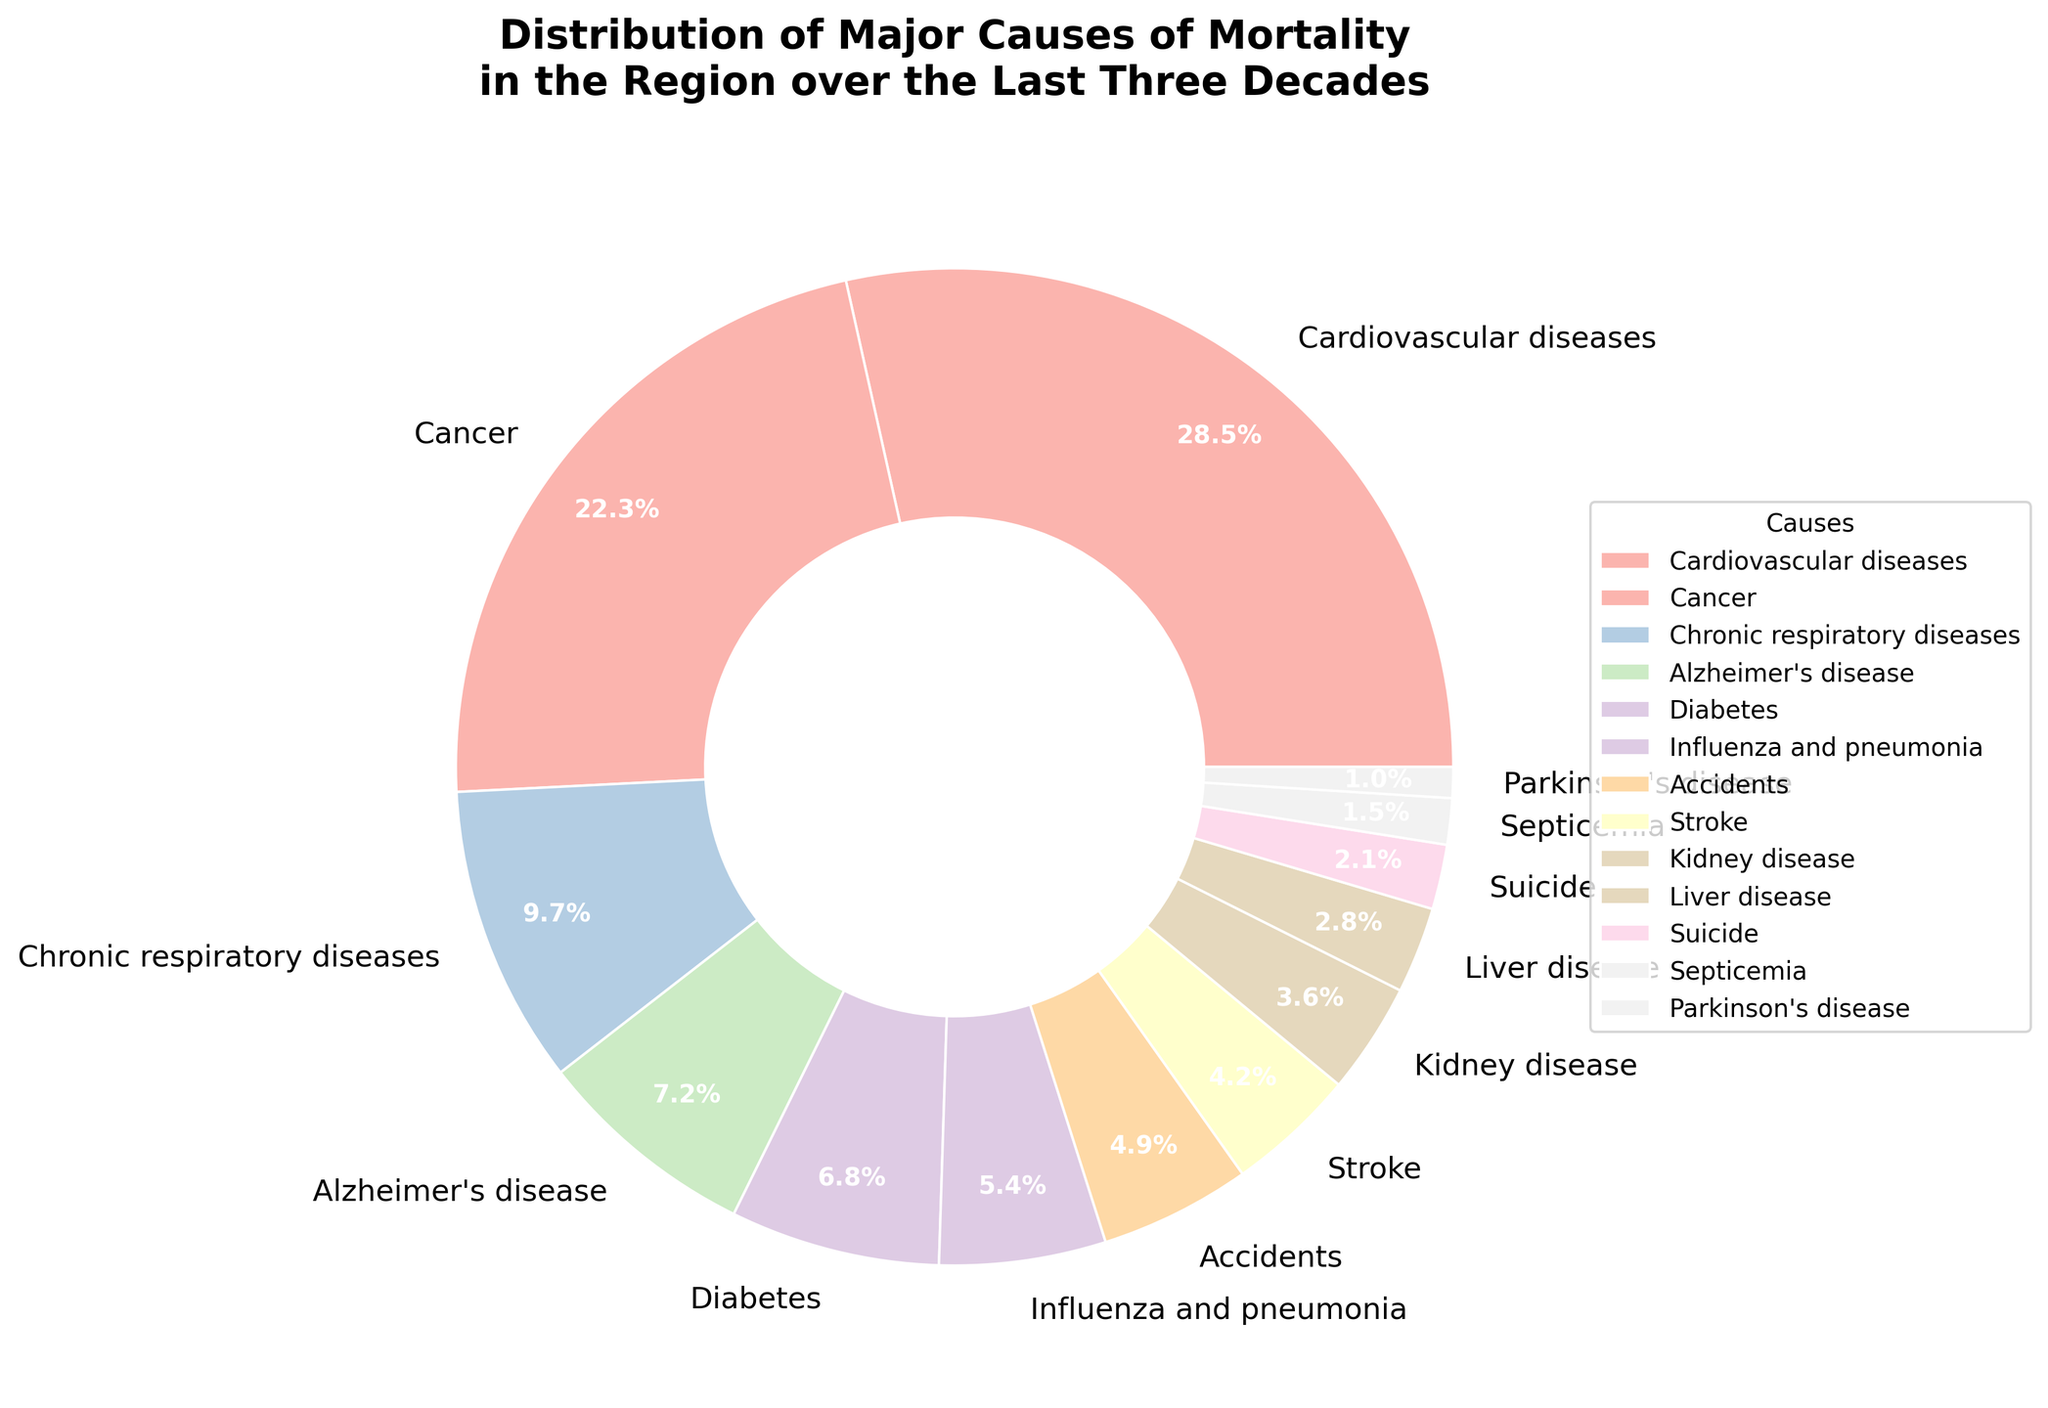Which cause of mortality has the highest percentage? The figure's pie chart segment that occupies the largest area corresponds to Cardiovascular diseases.
Answer: Cardiovascular diseases Which cause of mortality has the lowest percentage? The pie chart segment with the smallest area belongs to Parkinson's disease, suggesting it has the lowest percentage.
Answer: Parkinson's disease What is the combined percentage of deaths due to Alzheimer's disease, Diabetes, and Influenza and pneumonia? Sum the percentages: 7.2% (Alzheimer's disease) + 6.8% (Diabetes) + 5.4% (Influenza and pneumonia) = 19.4%.
Answer: 19.4% How does the percentage of deaths caused by Cancer compare to Chronic respiratory diseases? Cancer has a higher percentage (22.3%) compared to Chronic respiratory diseases (9.7%).
Answer: Cancer has a higher percentage Which causes of mortality account for approximately half of the deaths? Add the highest percentages until the sum is close to 50%: 28.5% (Cardiovascular diseases) + 22.3% (Cancer) = 50.8%.
Answer: Cardiovascular diseases and Cancer What is the percentage difference between deaths caused by Accidents and Stroke? Subtract Stroke percentage from Accidents: 4.9% (Accidents) - 4.2% (Stroke) = 0.7%.
Answer: 0.7% Are deaths caused by Kidney disease more or less than those caused by Liver disease? Compare the percentages: Kidney disease (3.6%) and Liver disease (2.8%). Kidney disease is more.
Answer: More What is the combined percentage of the three least frequent causes of mortality? Sum the percentages: 1.0% (Parkinson's disease) + 1.5% (Septicemia) + 2.1% (Suicide) = 4.6%.
Answer: 4.6% If the percentages of Influenza and pneumonia and Accidents were combined, how would it compare to the percentage of Diabetes? Combine percentages: 5.4% (Influenza and pneumonia) + 4.9% (Accidents) = 10.3%, which is greater than Diabetes (6.8%).
Answer: Greater Which three causes of mortality, when combined, equal nearly the percentage of Cardiovascular diseases? Sum percentages to match 28.5%: 9.7% (Chronic respiratory diseases) + 7.2% (Alzheimer's disease) + 6.8% (Diabetes) = 23.7%. Adding 4.9% (Accidents) equals 28.6%, close enough.
Answer: Chronic respiratory diseases, Alzheimer's disease, and Accidents 